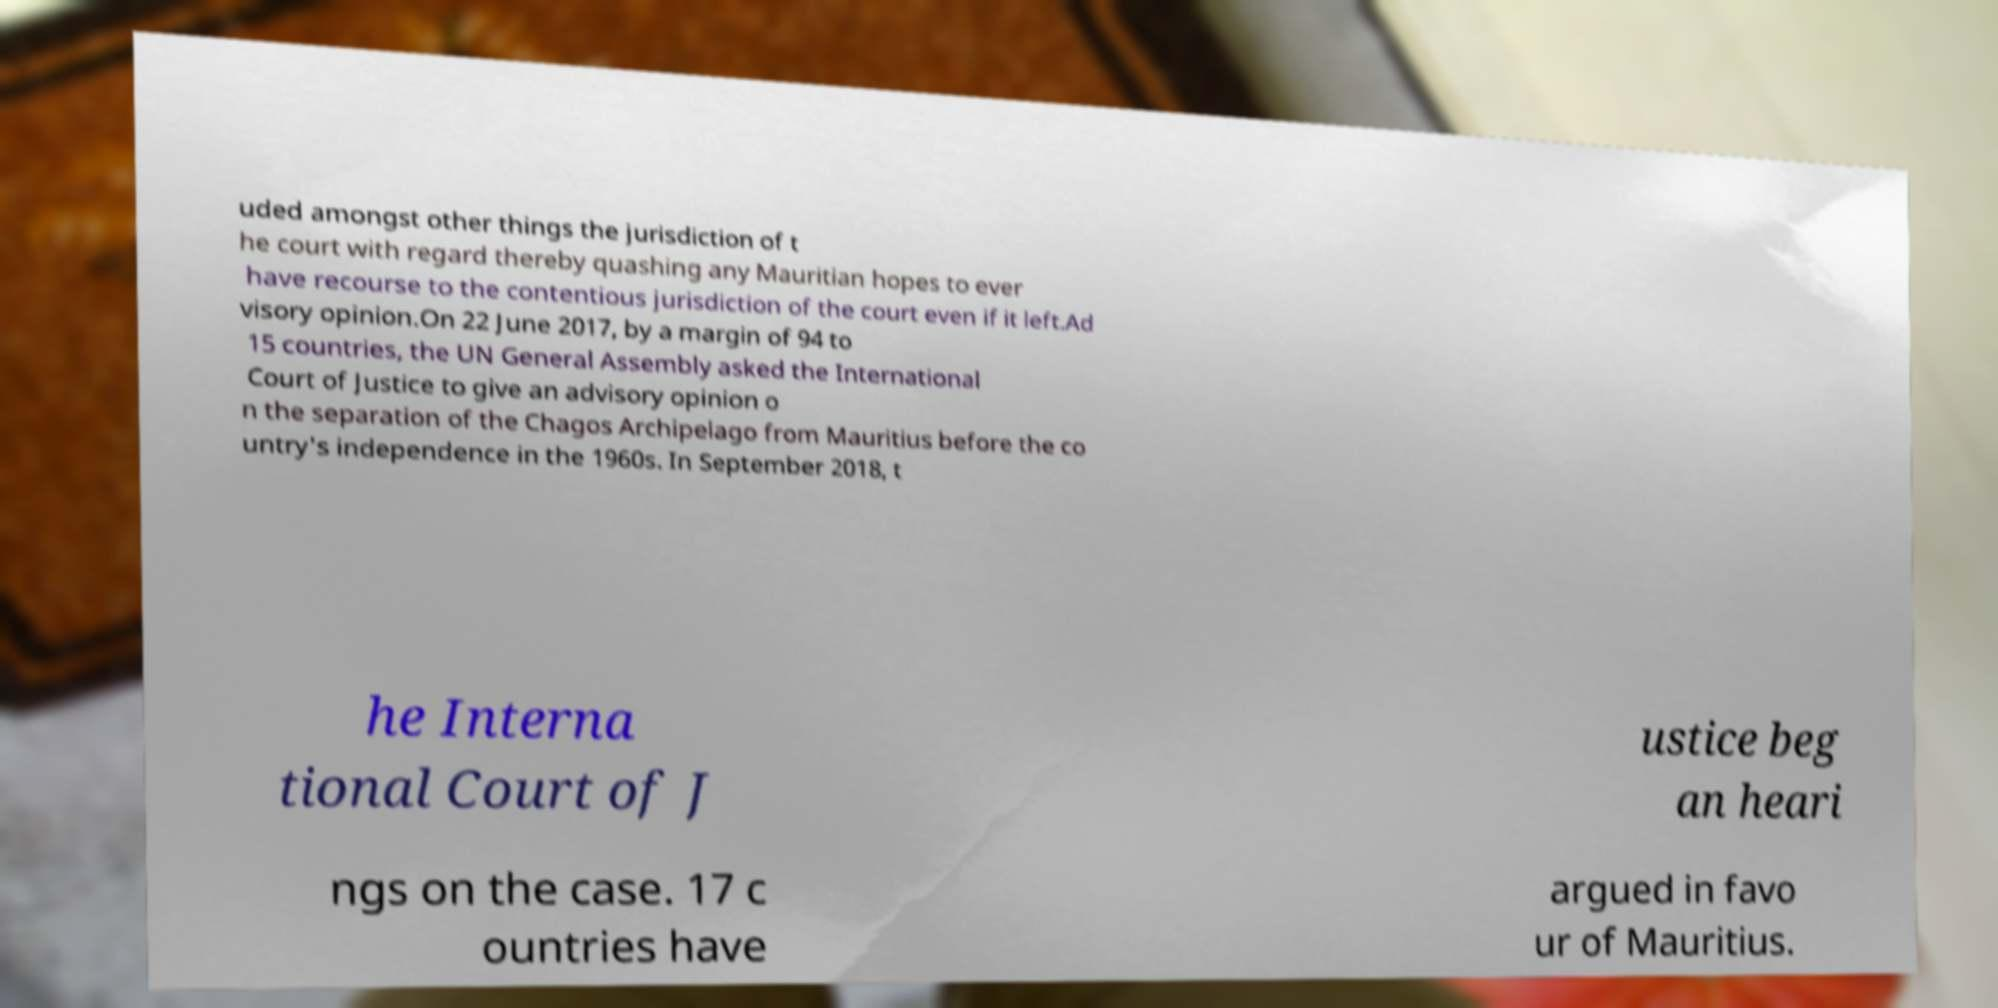Please identify and transcribe the text found in this image. uded amongst other things the jurisdiction of t he court with regard thereby quashing any Mauritian hopes to ever have recourse to the contentious jurisdiction of the court even if it left.Ad visory opinion.On 22 June 2017, by a margin of 94 to 15 countries, the UN General Assembly asked the International Court of Justice to give an advisory opinion o n the separation of the Chagos Archipelago from Mauritius before the co untry's independence in the 1960s. In September 2018, t he Interna tional Court of J ustice beg an heari ngs on the case. 17 c ountries have argued in favo ur of Mauritius. 